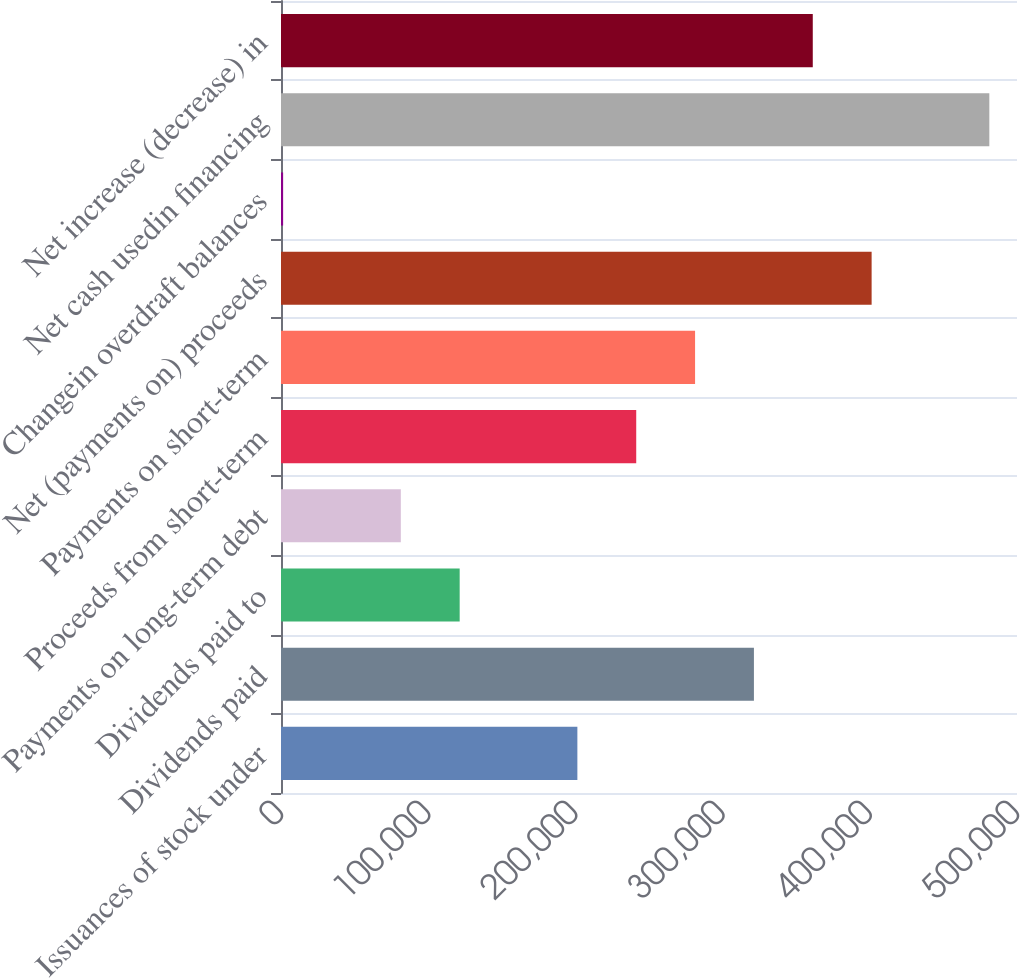Convert chart. <chart><loc_0><loc_0><loc_500><loc_500><bar_chart><fcel>Issuances of stock under<fcel>Dividends paid<fcel>Dividends paid to<fcel>Payments on long-term debt<fcel>Proceeds from short-term<fcel>Payments on short-term<fcel>Net (payments on) proceeds<fcel>Changein overdraft balances<fcel>Net cash usedin financing<fcel>Net increase (decrease) in<nl><fcel>201340<fcel>321279<fcel>121380<fcel>81400.6<fcel>241320<fcel>281300<fcel>401239<fcel>1441<fcel>481199<fcel>361259<nl></chart> 